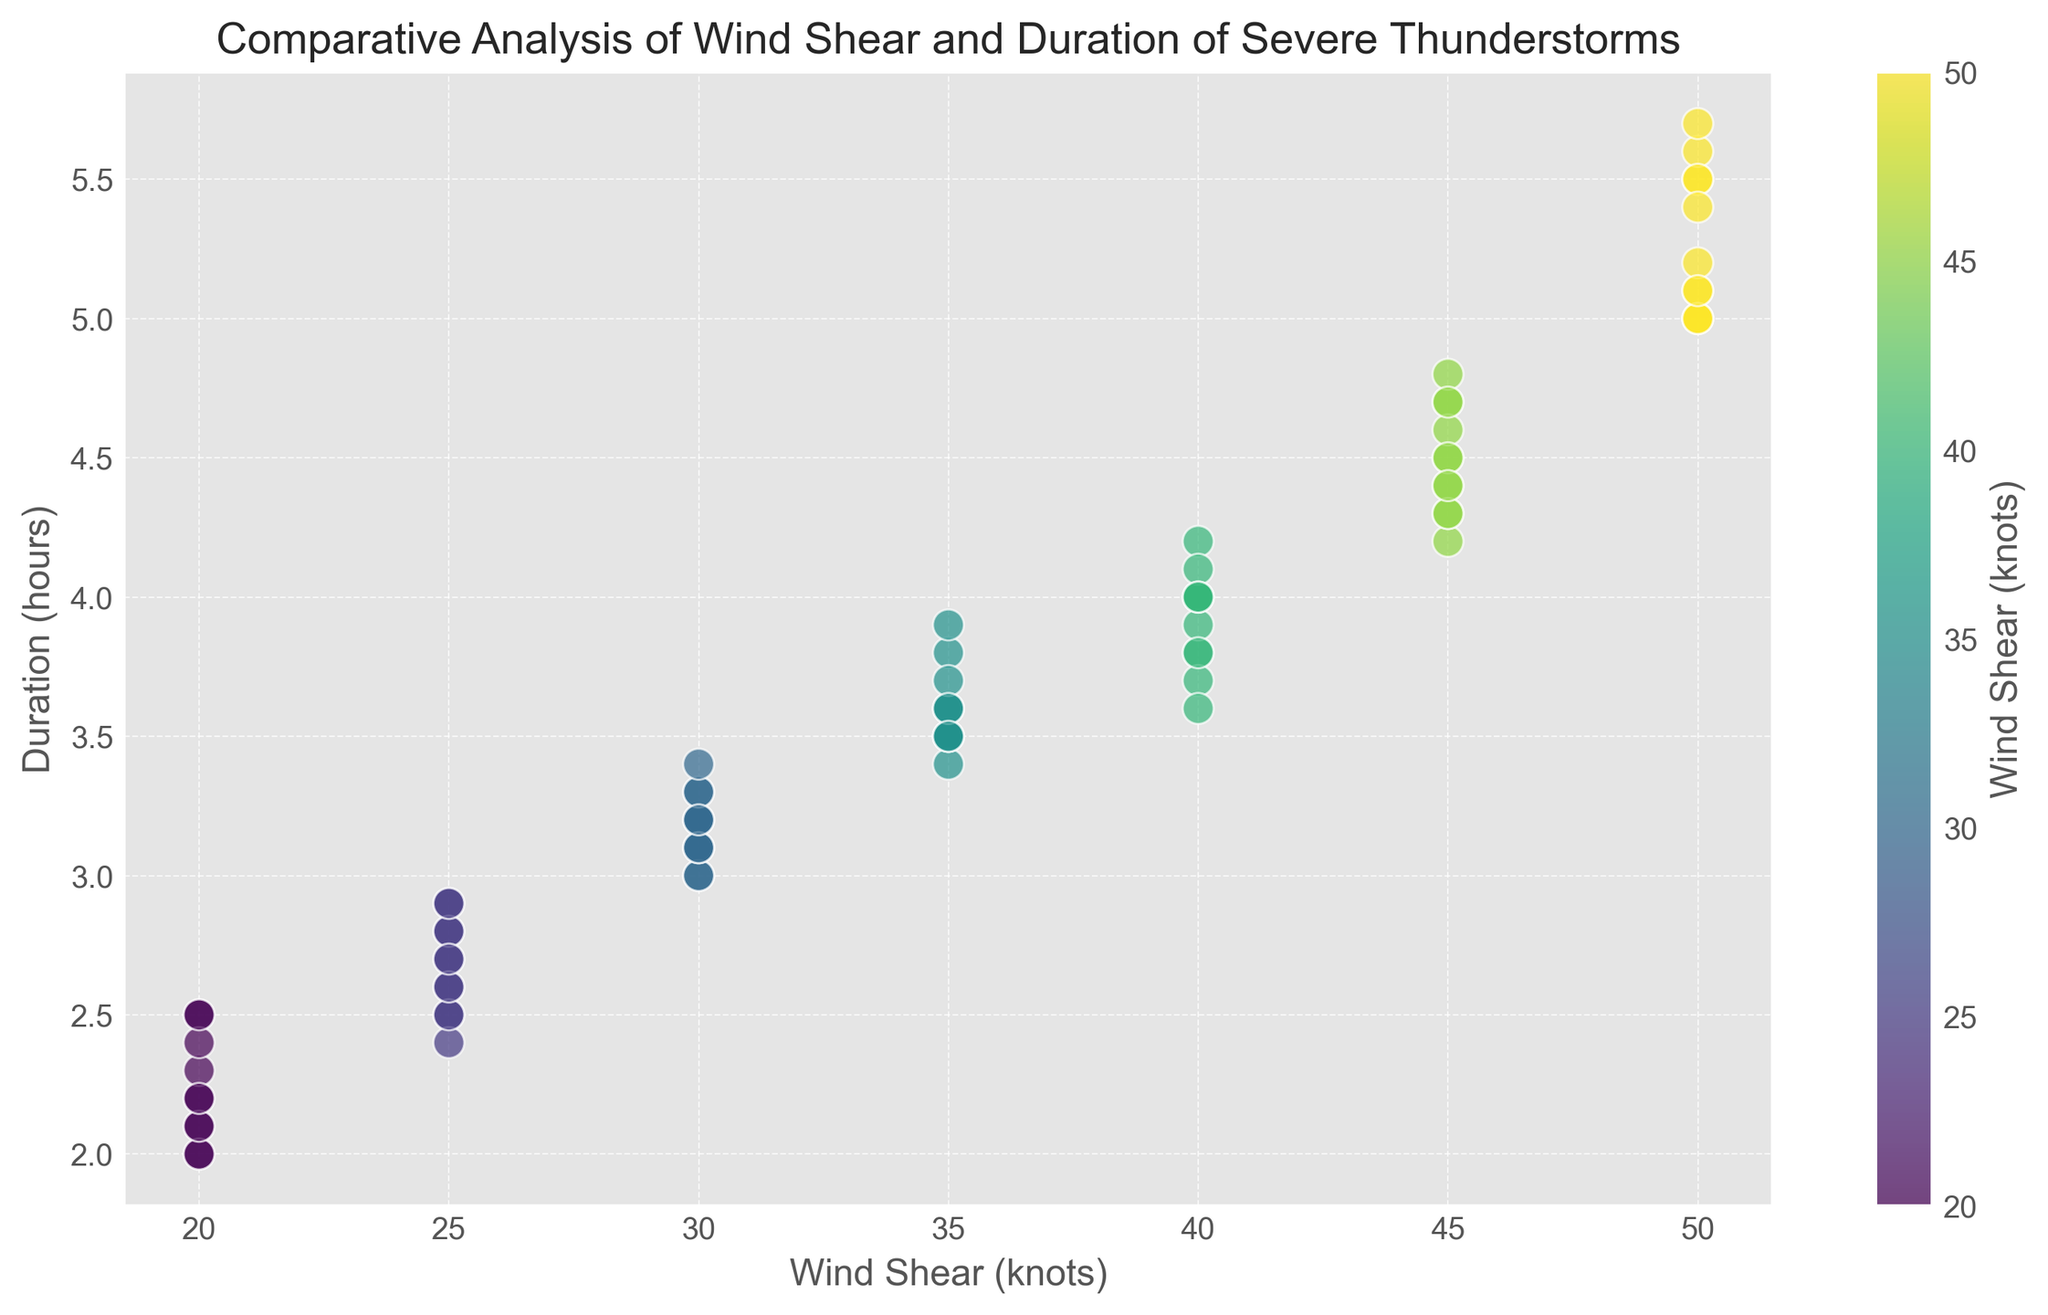What is the average duration of thunderstorms with a wind shear of 40 knots? To find the average duration of thunderstorms with 40 knots wind shear, we need to list all the durations corresponding to 40 knots: 4, 3.8, 4.2, 3.9, 4, 4.1, and 4. The average is (4 + 3.8 + 4.2 + 3.9 + 4 + 4.1 + 4)/7 = 4
Answer: 4 Which wind shear rate corresponds to the longest duration of severe thunderstorms? The longest duration seen on the plot is 5.7 hours. Checking the figure, this duration corresponds to a wind shear rate of 50 knots
Answer: 50 knots In which wind shear range do most of the durations of severe thunderstorms fall short (less than 3 hours)? By examining the plot, the durations less than 3 hours fall mostly within wind shear ranges of 20 and 25 knots
Answer: 20 and 25 knots Is there any wind shear measurement that appears with both the shortest and the longest durations? By looking at the plot, durations range from 2.0 to 5.7 hours. The shortest duration is 2.0 hours (with 20 knots) and the longest is 5.7 hours (with 50 knots). No wind shear measurement has both these durations
Answer: No Which wind shear is associated with a duration of approximately 3.3 hours? Checking the plot, a duration of 3.3 hours corresponds to a wind shear of 30 knots
Answer: 30 knots For wind shears of 45 knots, what are the different durations observed? By noting all durations that align with a wind shear of 45 knots from the plot, these are 4.2, 4.7, 4.3, 4.8, 4.6, and 4.5 hours
Answer: 4.2, 4.7, 4.3, 4.8, 4.6, 4.5 hours How is the color of the points in the scatter plot represented? The color of the points in the scatter plot follows a gradient from blue to green, representing increasing wind shear values as per the color bar
Answer: Gradient from blue to green Comparing the durations of thunderstorms with 30 knots and 50 knots of wind shear, which generally has longer durations? From the visual plot, the durations for 50 knots mostly range between 5, and 5.7 hours, while for 30 knots, they vary around 3, 3.2, 3.1, 3.3, 3.1, and 3.2 hours, indicating that 50 knots has generally longer durations
Answer: 50 knots What can be said about the relationship between wind shear and duration of thunderstorms? Observing the scatter plot, as wind shear increases (from 20 to 50 knots), we generally see an increase in the duration of severe thunderstorms
Answer: Positive correlation Which wind shear value shows the least variance in the duration of thunderstorms? By examining the scatter plot, we can see that the durations for wind shear of 20 knots are mostly clustered around 2 to 2.5 hours, indicating the least variance
Answer: 20 knots 